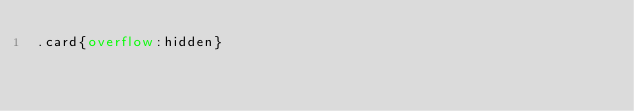<code> <loc_0><loc_0><loc_500><loc_500><_CSS_>.card{overflow:hidden}</code> 